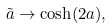<formula> <loc_0><loc_0><loc_500><loc_500>\tilde { a } \rightarrow \cosh ( 2 a ) ,</formula> 